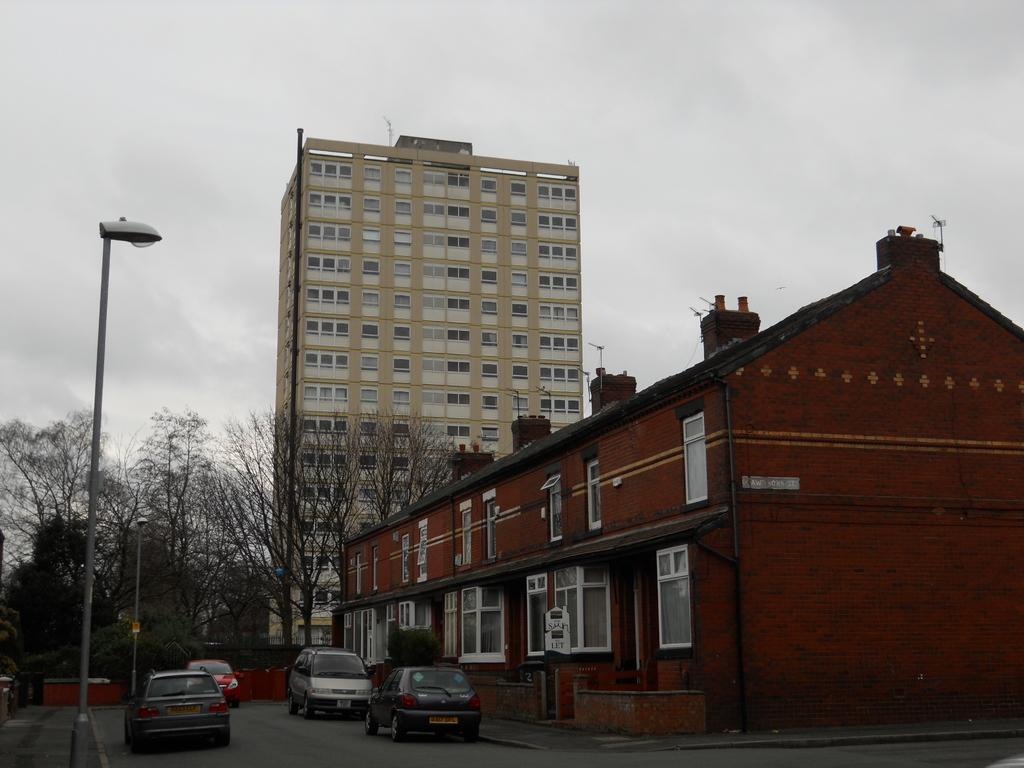What type of structures can be seen in the image? There are buildings in the image. What natural elements are present in the image? There are trees in the image. What man-made objects can be seen in the image? There are poles in the image. What artificial light source is visible in the image? There is a light in the image. What is visible in the sky at the top of the image? The sky with clouds is visible at the top of the image. What type of transportation is visible at the bottom of the image? Cars on the road are visible at the bottom of the image. What type of quartz can be seen in the image? There is no quartz present in the image. What vegetables are growing on the trees in the image? There are no vegetables growing on the trees in the image; the trees are not depicted as having any fruit or vegetation. 